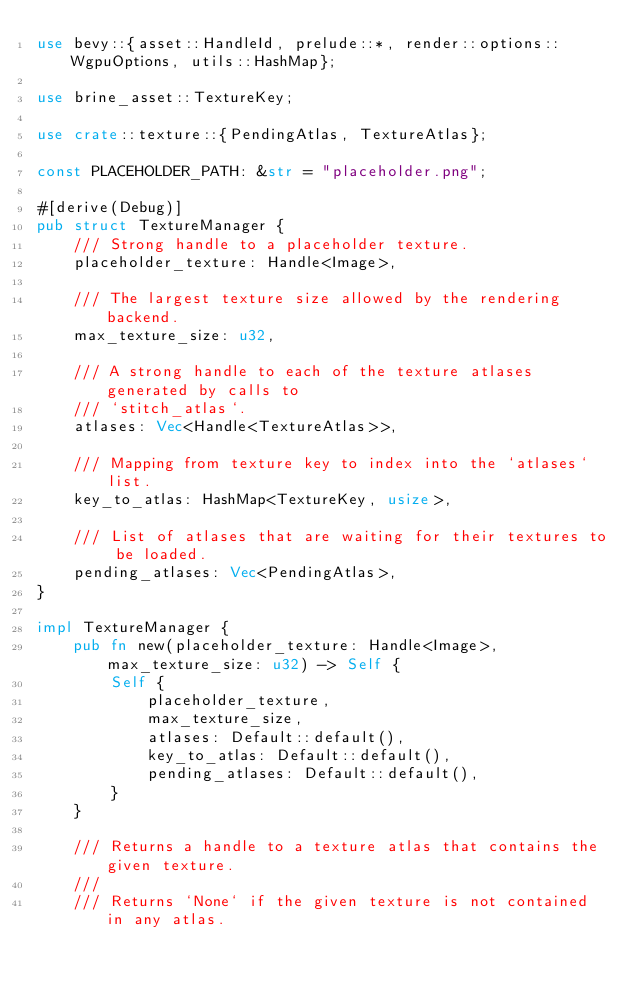Convert code to text. <code><loc_0><loc_0><loc_500><loc_500><_Rust_>use bevy::{asset::HandleId, prelude::*, render::options::WgpuOptions, utils::HashMap};

use brine_asset::TextureKey;

use crate::texture::{PendingAtlas, TextureAtlas};

const PLACEHOLDER_PATH: &str = "placeholder.png";

#[derive(Debug)]
pub struct TextureManager {
    /// Strong handle to a placeholder texture.
    placeholder_texture: Handle<Image>,

    /// The largest texture size allowed by the rendering backend.
    max_texture_size: u32,

    /// A strong handle to each of the texture atlases generated by calls to
    /// `stitch_atlas`.
    atlases: Vec<Handle<TextureAtlas>>,

    /// Mapping from texture key to index into the `atlases` list.
    key_to_atlas: HashMap<TextureKey, usize>,

    /// List of atlases that are waiting for their textures to be loaded.
    pending_atlases: Vec<PendingAtlas>,
}

impl TextureManager {
    pub fn new(placeholder_texture: Handle<Image>, max_texture_size: u32) -> Self {
        Self {
            placeholder_texture,
            max_texture_size,
            atlases: Default::default(),
            key_to_atlas: Default::default(),
            pending_atlases: Default::default(),
        }
    }

    /// Returns a handle to a texture atlas that contains the given texture.
    ///
    /// Returns `None` if the given texture is not contained in any atlas.</code> 